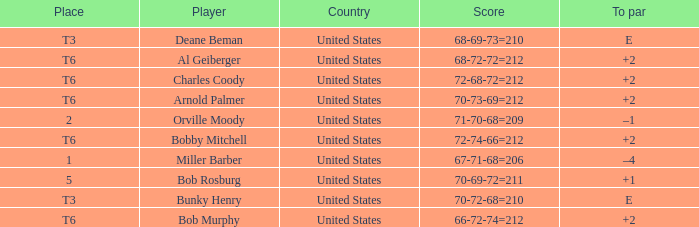What is the place of the 68-69-73=210? T3. 